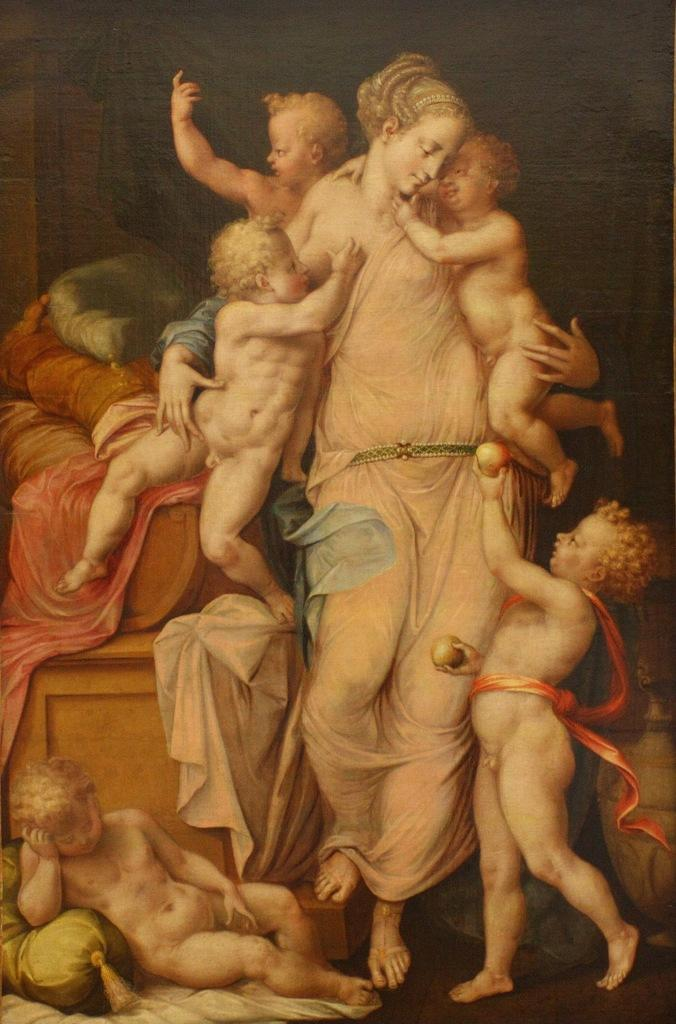What is the main subject of the image? There is a painting in the image. What is the painting depicting? The painting depicts a woman. What is the woman doing in the painting? The woman is holding babies in the painting. What type of reaction can be seen from the pig in the painting? There is no pig present in the painting; it depicts a woman holding babies. 